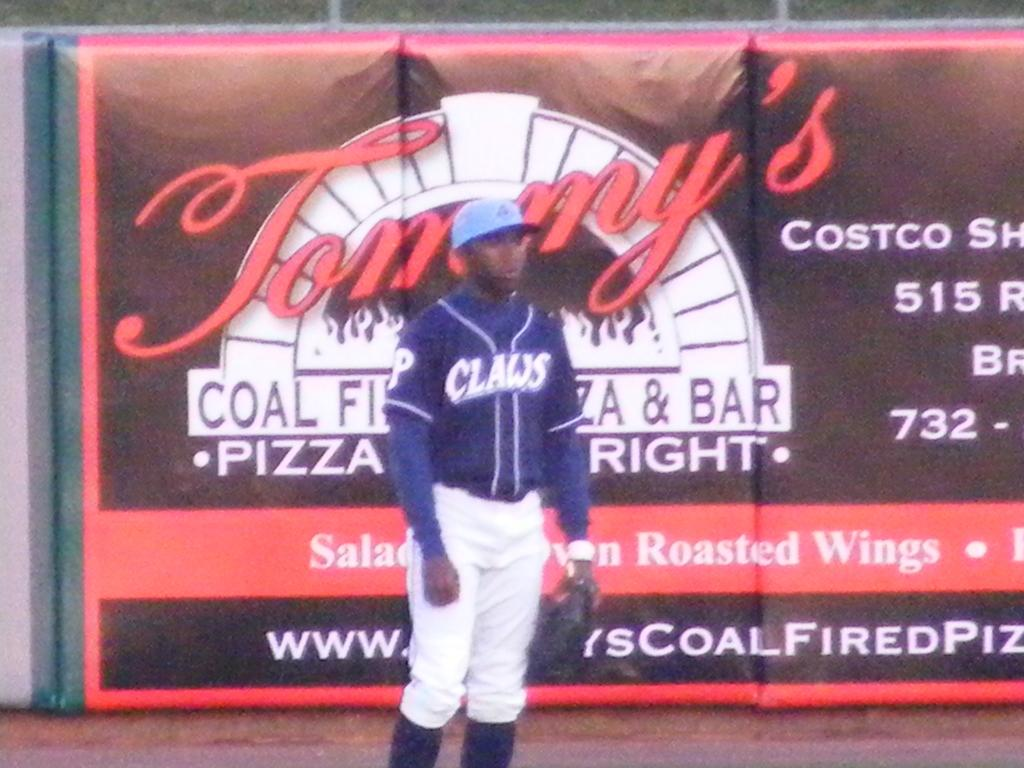<image>
Render a clear and concise summary of the photo. a baseball player from the claws standing infront of an advertisement for tommy's 